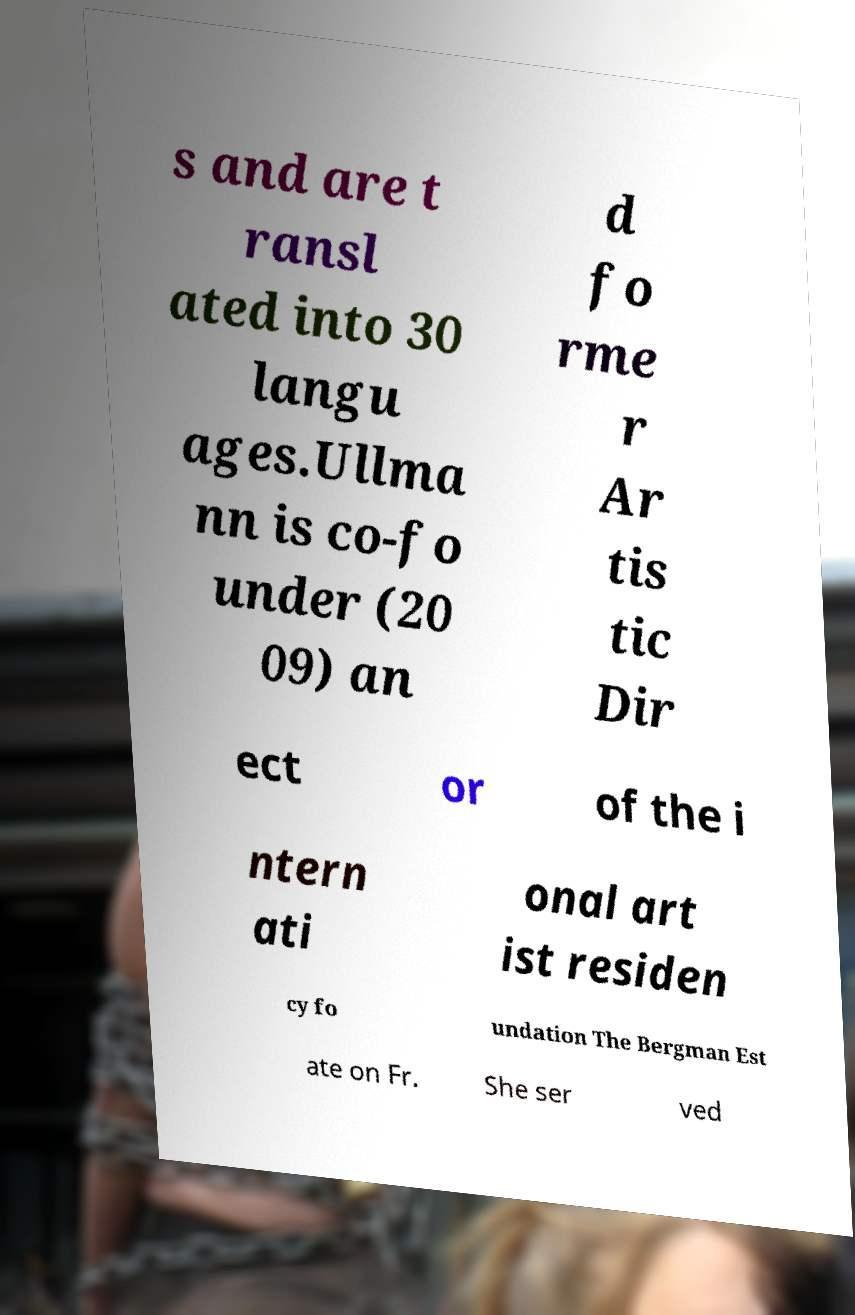I need the written content from this picture converted into text. Can you do that? s and are t ransl ated into 30 langu ages.Ullma nn is co-fo under (20 09) an d fo rme r Ar tis tic Dir ect or of the i ntern ati onal art ist residen cy fo undation The Bergman Est ate on Fr. She ser ved 